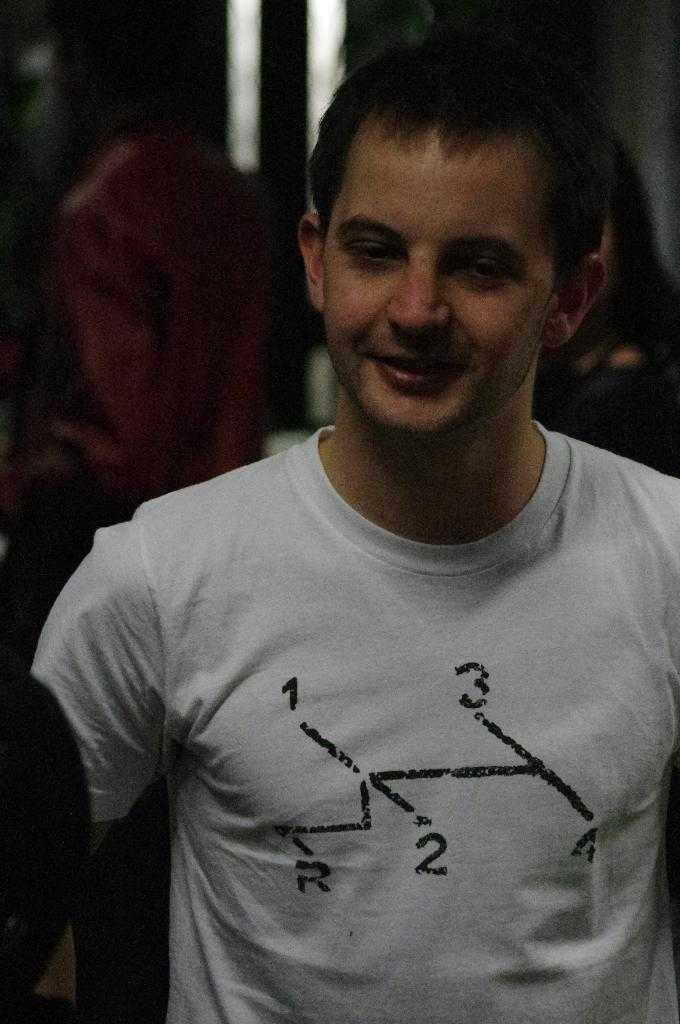What is the main subject in the foreground of the image? There is a man in the foreground of the image. What is the man wearing in the image? The man is wearing a white T-shirt in the image. Can you describe the man's hair color in the image? The man has black hair in the image. What type of knowledge is the man sharing with the cars in the image? There are no cars present in the image, and therefore no interaction between the man and cars can be observed. 